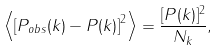Convert formula to latex. <formula><loc_0><loc_0><loc_500><loc_500>\left \langle \left [ P _ { o b s } ( k ) - P ( k ) \right ] ^ { 2 } \right \rangle = \frac { [ P ( k ) ] ^ { 2 } } { N _ { k } } ,</formula> 